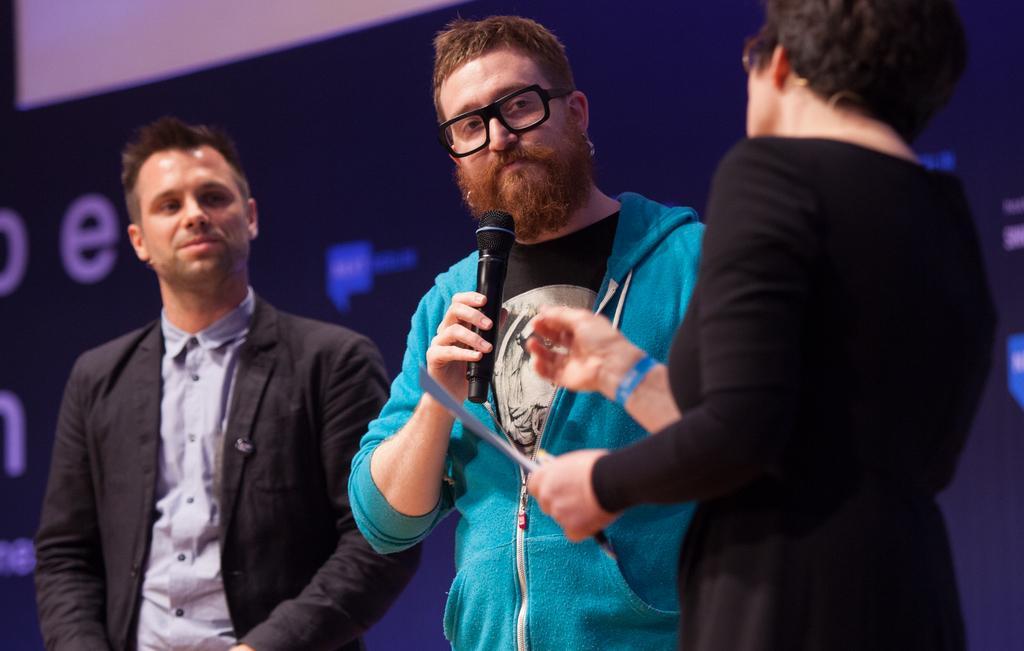Please provide a concise description of this image. In this image there are three person. The middle one is holding a mic and the backside here is a screen. 